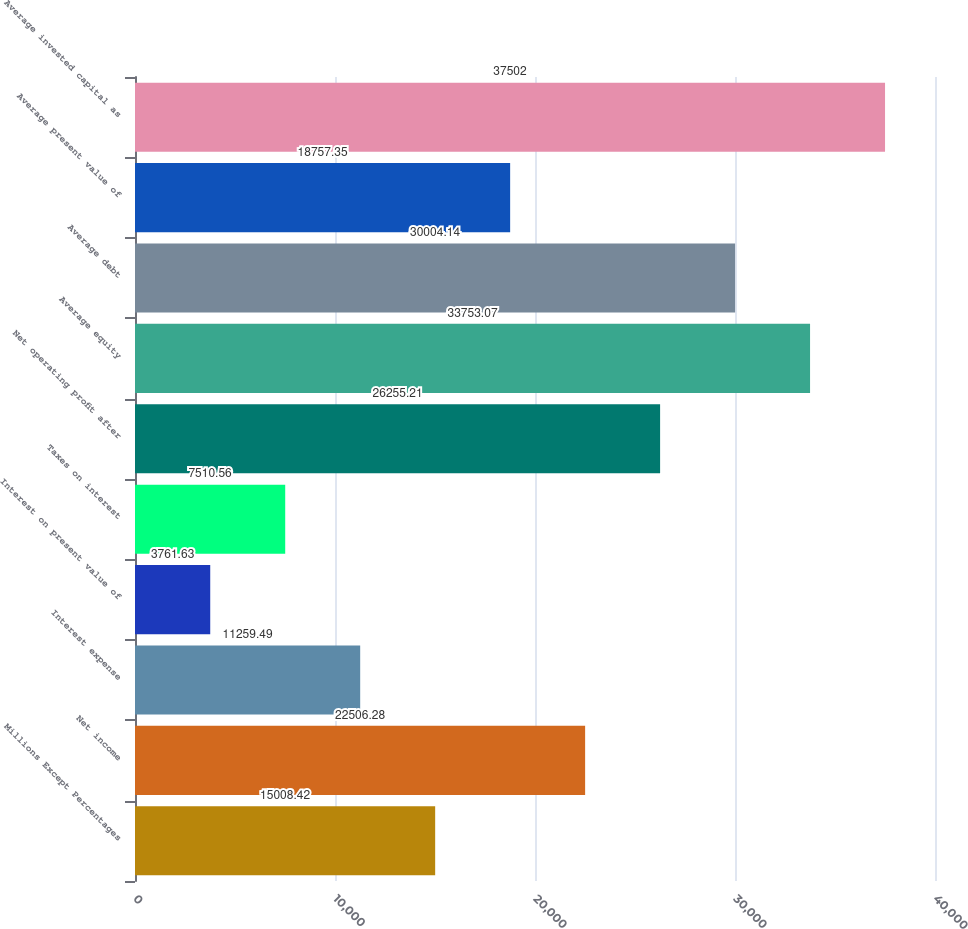<chart> <loc_0><loc_0><loc_500><loc_500><bar_chart><fcel>Millions Except Percentages<fcel>Net income<fcel>Interest expense<fcel>Interest on present value of<fcel>Taxes on interest<fcel>Net operating profit after<fcel>Average equity<fcel>Average debt<fcel>Average present value of<fcel>Average invested capital as<nl><fcel>15008.4<fcel>22506.3<fcel>11259.5<fcel>3761.63<fcel>7510.56<fcel>26255.2<fcel>33753.1<fcel>30004.1<fcel>18757.3<fcel>37502<nl></chart> 